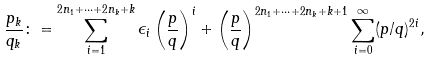Convert formula to latex. <formula><loc_0><loc_0><loc_500><loc_500>\frac { p _ { k } } { q _ { k } } \colon = \sum _ { i = 1 } ^ { 2 n _ { 1 } + \cdots + 2 n _ { k } + k } \epsilon _ { i } \left ( \frac { p } { q } \right ) ^ { i } + \left ( \frac { p } { q } \right ) ^ { 2 n _ { 1 } + \cdots + 2 n _ { k } + k + 1 } \sum _ { i = 0 } ^ { \infty } ( p / q ) ^ { 2 i } ,</formula> 